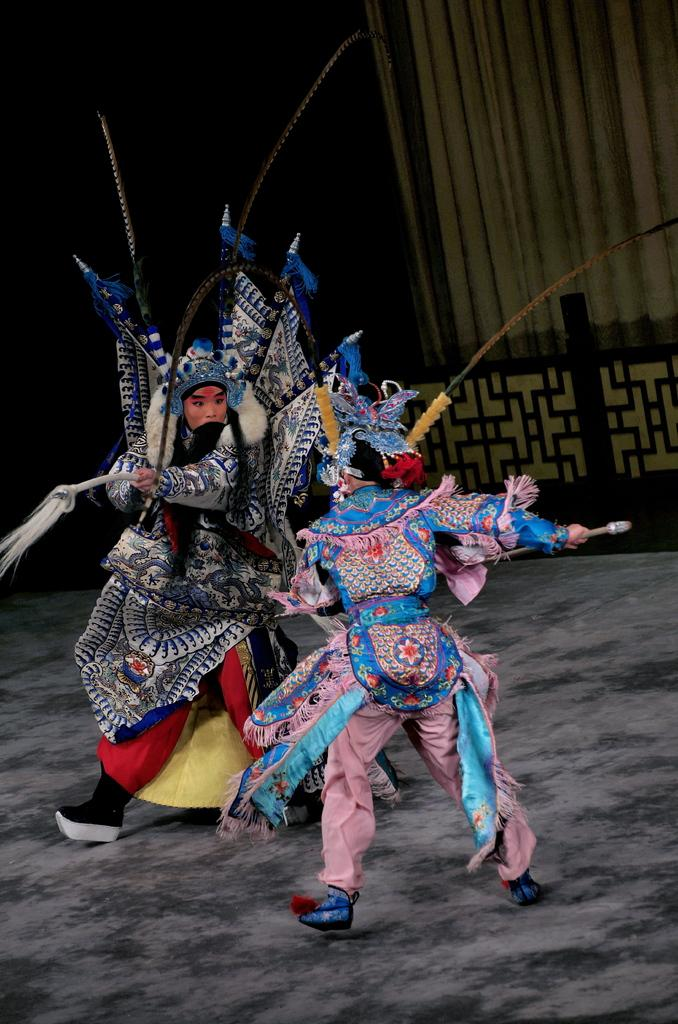How many people are in the image? There are two persons in the image. What are the persons holding in their hands? The persons are holding an object in their hands. What colors are the costumes of the two persons? One person is wearing a pink costume, and the other person is wearing a blue costume. What can be seen in the background of the image? There is a curtain in the backdrop of the image. What type of knowledge is the person wearing the pink costume sharing with the person wearing the blue costume in the image? There is no indication in the image that the persons are sharing knowledge or engaging in any activity related to knowledge. 